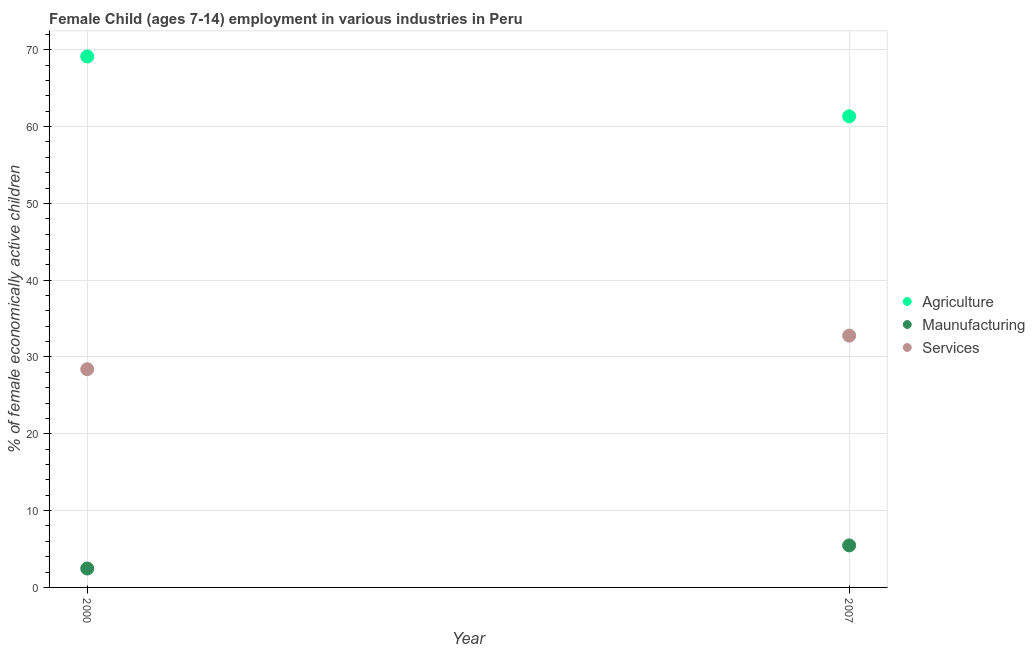How many different coloured dotlines are there?
Keep it short and to the point. 3. What is the percentage of economically active children in manufacturing in 2000?
Provide a short and direct response. 2.46. Across all years, what is the maximum percentage of economically active children in manufacturing?
Offer a very short reply. 5.47. Across all years, what is the minimum percentage of economically active children in services?
Provide a short and direct response. 28.41. In which year was the percentage of economically active children in agriculture minimum?
Offer a very short reply. 2007. What is the total percentage of economically active children in agriculture in the graph?
Your answer should be compact. 130.46. What is the difference between the percentage of economically active children in manufacturing in 2000 and that in 2007?
Make the answer very short. -3.01. What is the difference between the percentage of economically active children in services in 2007 and the percentage of economically active children in manufacturing in 2000?
Your answer should be compact. 30.32. What is the average percentage of economically active children in agriculture per year?
Ensure brevity in your answer.  65.23. In the year 2007, what is the difference between the percentage of economically active children in agriculture and percentage of economically active children in manufacturing?
Offer a very short reply. 55.86. In how many years, is the percentage of economically active children in manufacturing greater than 48 %?
Offer a very short reply. 0. What is the ratio of the percentage of economically active children in agriculture in 2000 to that in 2007?
Your response must be concise. 1.13. Is the percentage of economically active children in agriculture in 2000 less than that in 2007?
Make the answer very short. No. In how many years, is the percentage of economically active children in agriculture greater than the average percentage of economically active children in agriculture taken over all years?
Your answer should be compact. 1. Is it the case that in every year, the sum of the percentage of economically active children in agriculture and percentage of economically active children in manufacturing is greater than the percentage of economically active children in services?
Your answer should be compact. Yes. Is the percentage of economically active children in services strictly greater than the percentage of economically active children in manufacturing over the years?
Ensure brevity in your answer.  Yes. Is the percentage of economically active children in manufacturing strictly less than the percentage of economically active children in agriculture over the years?
Offer a terse response. Yes. How many years are there in the graph?
Make the answer very short. 2. What is the difference between two consecutive major ticks on the Y-axis?
Provide a succinct answer. 10. Are the values on the major ticks of Y-axis written in scientific E-notation?
Offer a very short reply. No. Does the graph contain any zero values?
Your answer should be very brief. No. Where does the legend appear in the graph?
Give a very brief answer. Center right. How many legend labels are there?
Your answer should be compact. 3. What is the title of the graph?
Provide a short and direct response. Female Child (ages 7-14) employment in various industries in Peru. What is the label or title of the Y-axis?
Offer a terse response. % of female economically active children. What is the % of female economically active children in Agriculture in 2000?
Your answer should be very brief. 69.13. What is the % of female economically active children of Maunufacturing in 2000?
Ensure brevity in your answer.  2.46. What is the % of female economically active children of Services in 2000?
Provide a short and direct response. 28.41. What is the % of female economically active children in Agriculture in 2007?
Your response must be concise. 61.33. What is the % of female economically active children of Maunufacturing in 2007?
Your response must be concise. 5.47. What is the % of female economically active children of Services in 2007?
Give a very brief answer. 32.78. Across all years, what is the maximum % of female economically active children of Agriculture?
Offer a terse response. 69.13. Across all years, what is the maximum % of female economically active children in Maunufacturing?
Your response must be concise. 5.47. Across all years, what is the maximum % of female economically active children in Services?
Your answer should be very brief. 32.78. Across all years, what is the minimum % of female economically active children of Agriculture?
Give a very brief answer. 61.33. Across all years, what is the minimum % of female economically active children in Maunufacturing?
Offer a terse response. 2.46. Across all years, what is the minimum % of female economically active children of Services?
Provide a succinct answer. 28.41. What is the total % of female economically active children of Agriculture in the graph?
Keep it short and to the point. 130.46. What is the total % of female economically active children in Maunufacturing in the graph?
Ensure brevity in your answer.  7.93. What is the total % of female economically active children of Services in the graph?
Offer a terse response. 61.19. What is the difference between the % of female economically active children in Maunufacturing in 2000 and that in 2007?
Offer a very short reply. -3.01. What is the difference between the % of female economically active children in Services in 2000 and that in 2007?
Provide a succinct answer. -4.37. What is the difference between the % of female economically active children in Agriculture in 2000 and the % of female economically active children in Maunufacturing in 2007?
Your response must be concise. 63.66. What is the difference between the % of female economically active children of Agriculture in 2000 and the % of female economically active children of Services in 2007?
Offer a terse response. 36.35. What is the difference between the % of female economically active children in Maunufacturing in 2000 and the % of female economically active children in Services in 2007?
Offer a very short reply. -30.32. What is the average % of female economically active children in Agriculture per year?
Make the answer very short. 65.23. What is the average % of female economically active children of Maunufacturing per year?
Provide a short and direct response. 3.96. What is the average % of female economically active children in Services per year?
Your answer should be very brief. 30.59. In the year 2000, what is the difference between the % of female economically active children of Agriculture and % of female economically active children of Maunufacturing?
Your answer should be very brief. 66.67. In the year 2000, what is the difference between the % of female economically active children of Agriculture and % of female economically active children of Services?
Keep it short and to the point. 40.72. In the year 2000, what is the difference between the % of female economically active children in Maunufacturing and % of female economically active children in Services?
Provide a succinct answer. -25.95. In the year 2007, what is the difference between the % of female economically active children in Agriculture and % of female economically active children in Maunufacturing?
Provide a succinct answer. 55.86. In the year 2007, what is the difference between the % of female economically active children of Agriculture and % of female economically active children of Services?
Make the answer very short. 28.55. In the year 2007, what is the difference between the % of female economically active children of Maunufacturing and % of female economically active children of Services?
Your answer should be compact. -27.31. What is the ratio of the % of female economically active children in Agriculture in 2000 to that in 2007?
Make the answer very short. 1.13. What is the ratio of the % of female economically active children of Maunufacturing in 2000 to that in 2007?
Provide a succinct answer. 0.45. What is the ratio of the % of female economically active children of Services in 2000 to that in 2007?
Keep it short and to the point. 0.87. What is the difference between the highest and the second highest % of female economically active children of Maunufacturing?
Your response must be concise. 3.01. What is the difference between the highest and the second highest % of female economically active children of Services?
Your response must be concise. 4.37. What is the difference between the highest and the lowest % of female economically active children of Maunufacturing?
Keep it short and to the point. 3.01. What is the difference between the highest and the lowest % of female economically active children of Services?
Your answer should be compact. 4.37. 